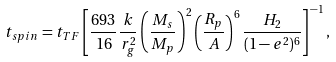Convert formula to latex. <formula><loc_0><loc_0><loc_500><loc_500>t _ { s p i n } = t _ { T F } \left [ \frac { 6 9 3 } { 1 6 } \frac { k } { r _ { g } ^ { 2 } } \left ( \frac { M _ { s } } { M _ { p } } \right ) ^ { 2 } \left ( \frac { R _ { p } } { A } \right ) ^ { 6 } \frac { H _ { 2 } } { ( 1 - e ^ { 2 } ) ^ { 6 } } \right ] ^ { - 1 } ,</formula> 